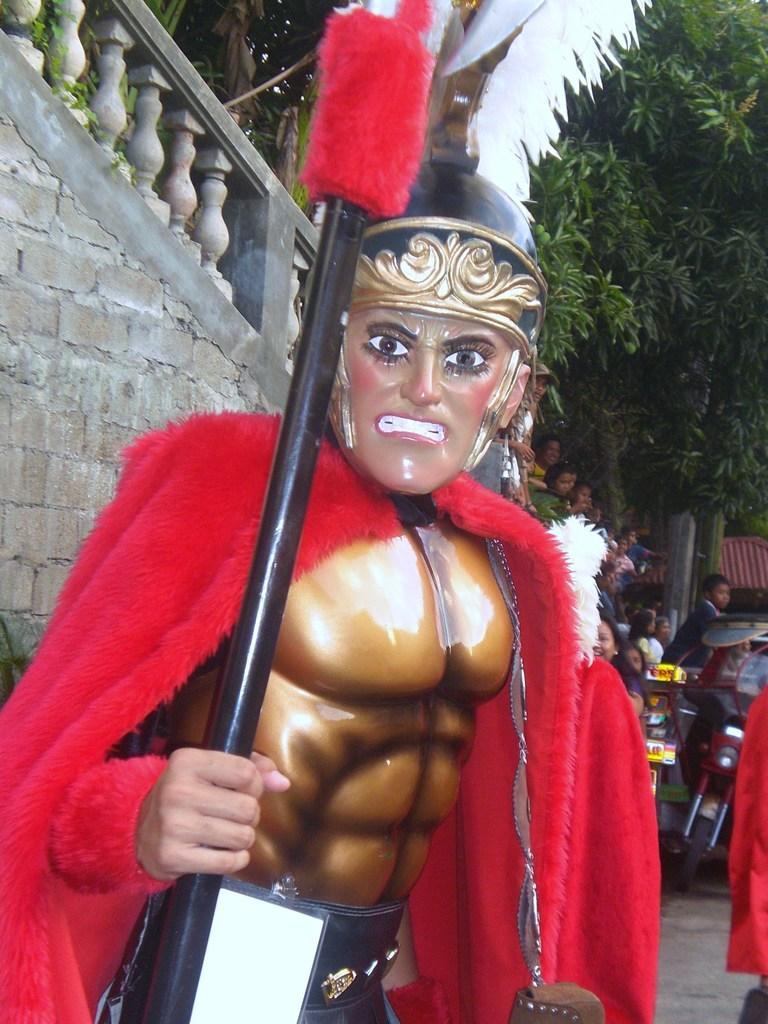Can you describe this image briefly? In the foreground of this image, there is a man wearing costume, mask and holding a stick in his hand. In the background, there is a trees, persons, motorbikes, railing and the wall. 